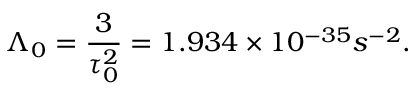<formula> <loc_0><loc_0><loc_500><loc_500>\Lambda _ { 0 } = \frac { 3 } { \tau _ { 0 } ^ { 2 } } = 1 . 9 3 4 \times 1 0 ^ { - 3 5 } s ^ { - 2 } .</formula> 